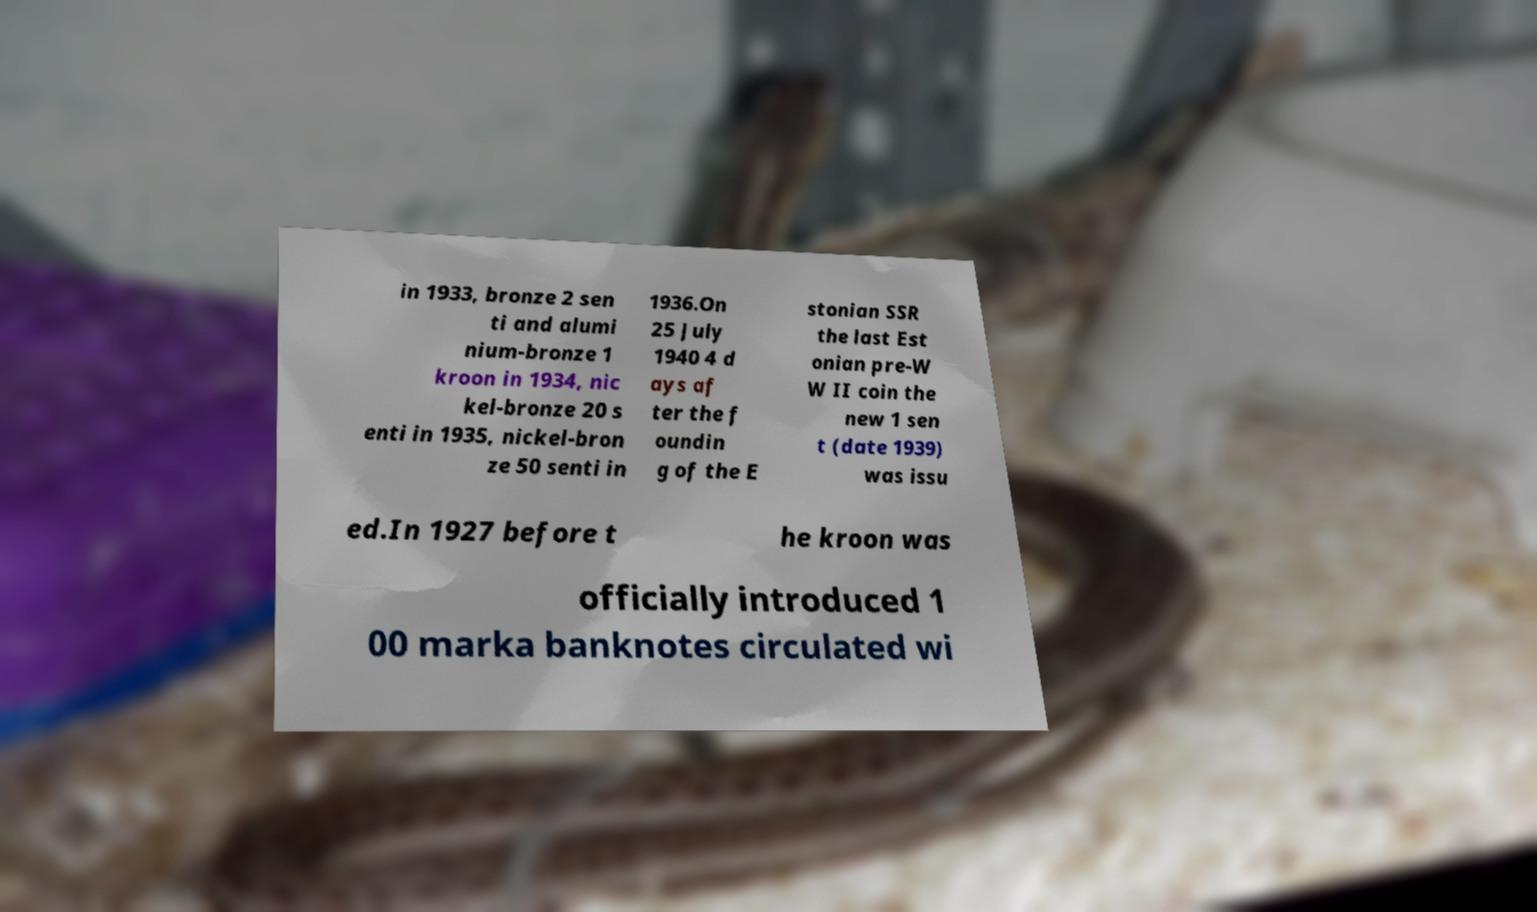There's text embedded in this image that I need extracted. Can you transcribe it verbatim? in 1933, bronze 2 sen ti and alumi nium-bronze 1 kroon in 1934, nic kel-bronze 20 s enti in 1935, nickel-bron ze 50 senti in 1936.On 25 July 1940 4 d ays af ter the f oundin g of the E stonian SSR the last Est onian pre-W W II coin the new 1 sen t (date 1939) was issu ed.In 1927 before t he kroon was officially introduced 1 00 marka banknotes circulated wi 